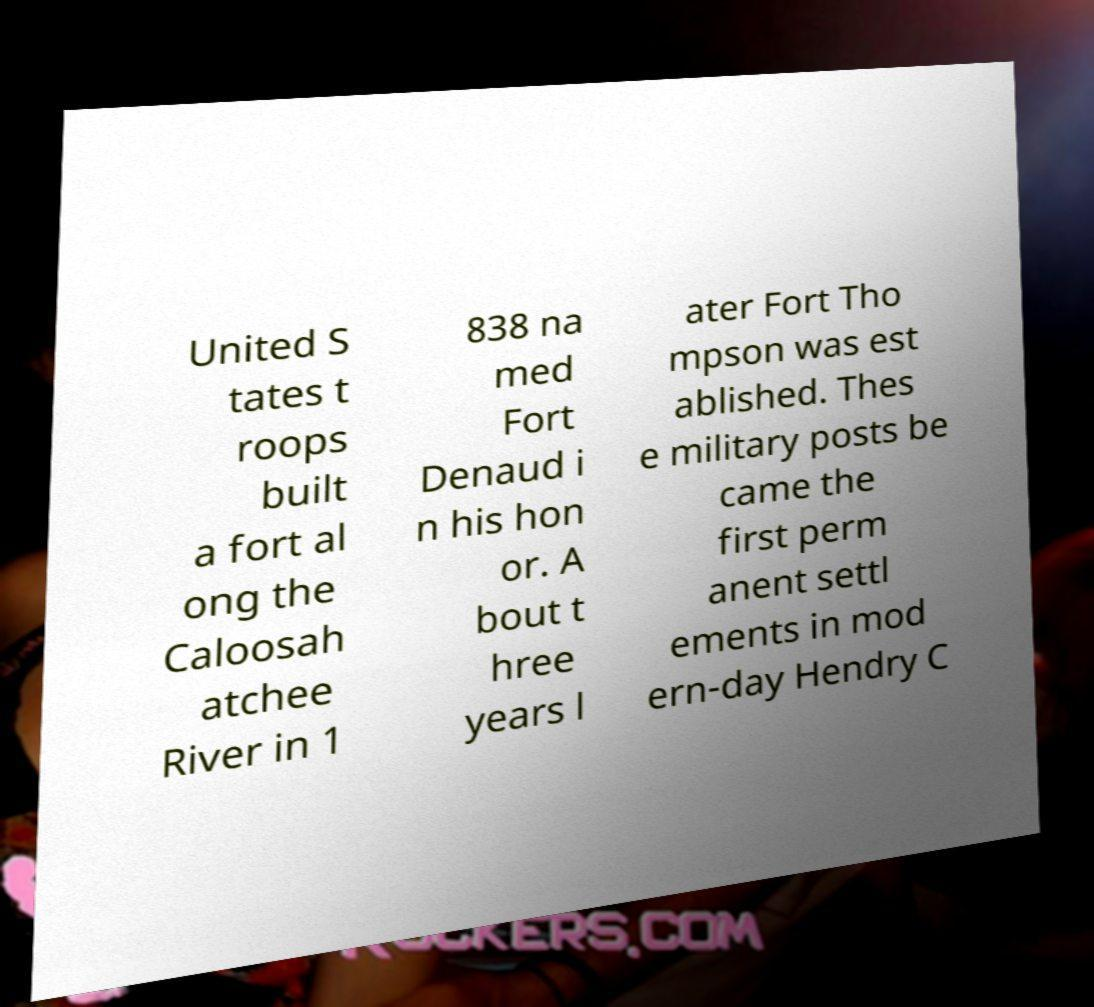Could you assist in decoding the text presented in this image and type it out clearly? United S tates t roops built a fort al ong the Caloosah atchee River in 1 838 na med Fort Denaud i n his hon or. A bout t hree years l ater Fort Tho mpson was est ablished. Thes e military posts be came the first perm anent settl ements in mod ern-day Hendry C 